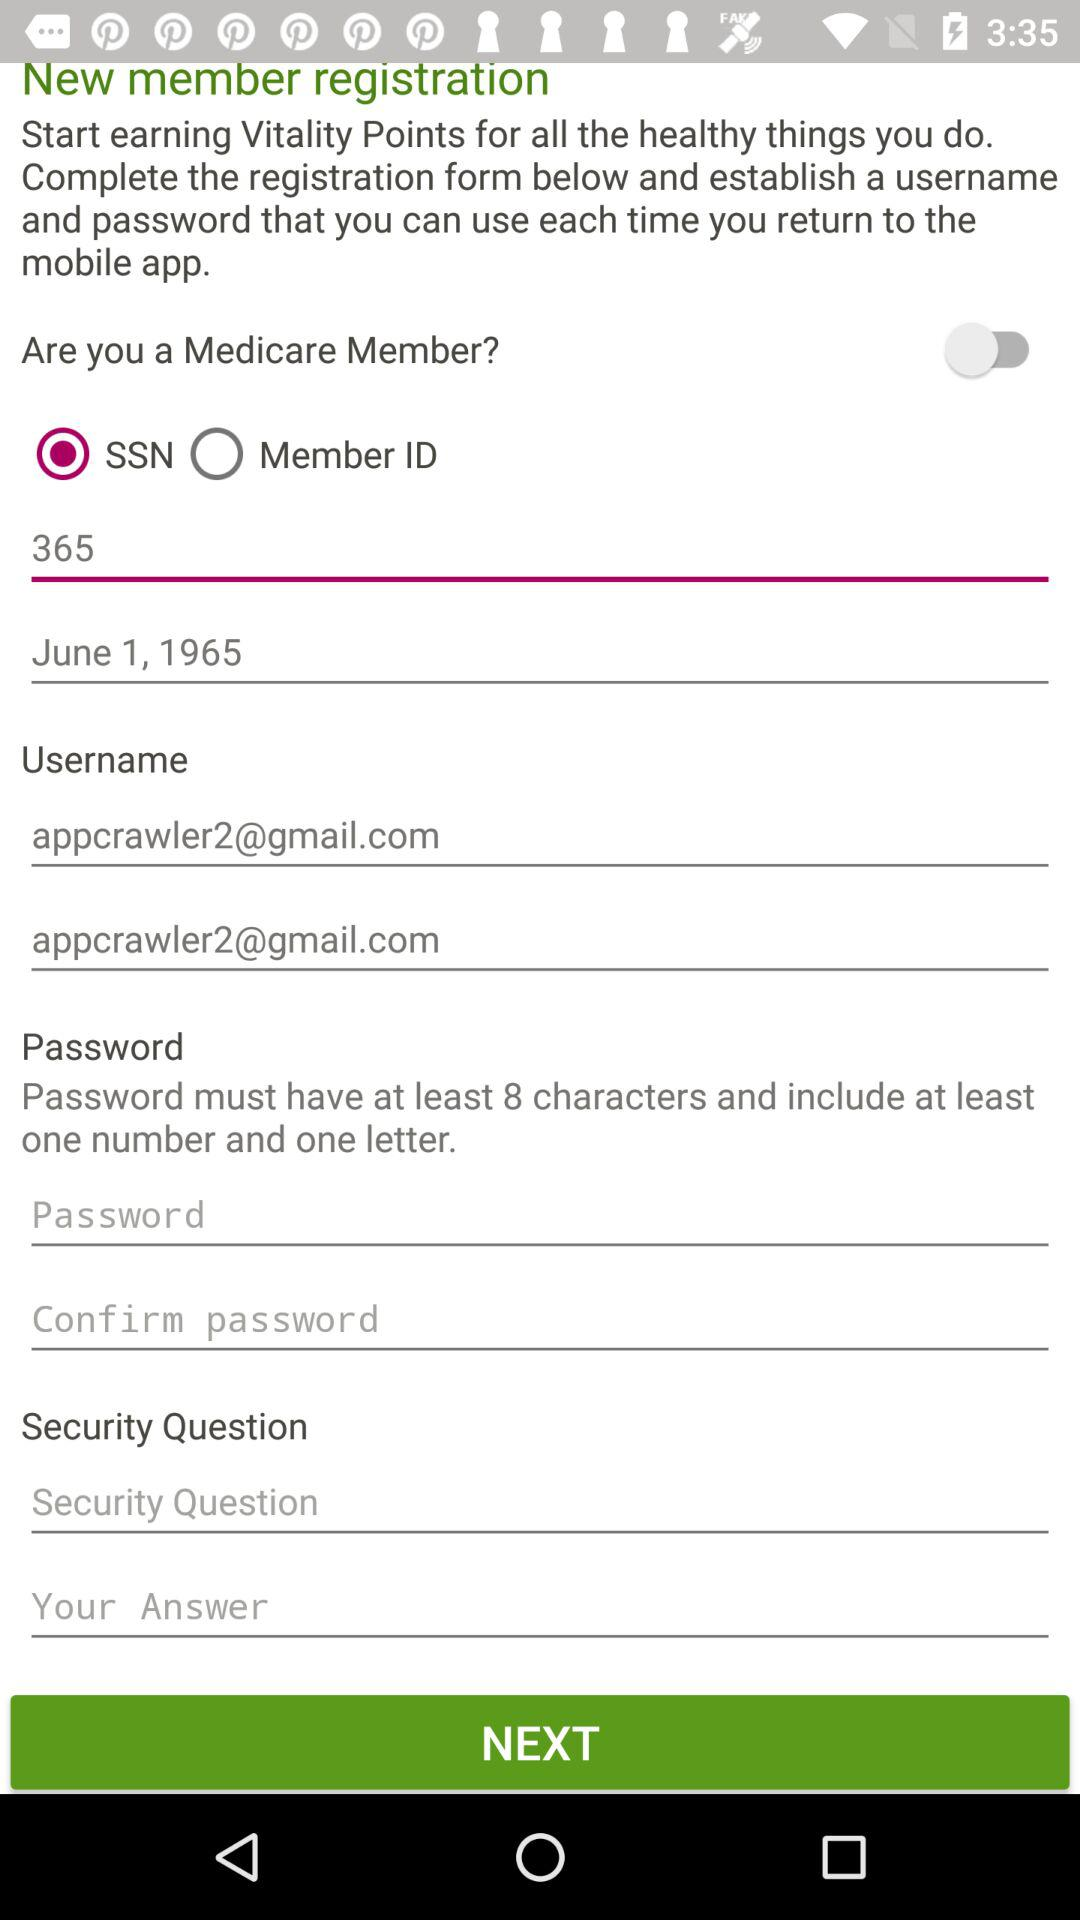What is the date of birth? The date of birth is June 1, 1965. 